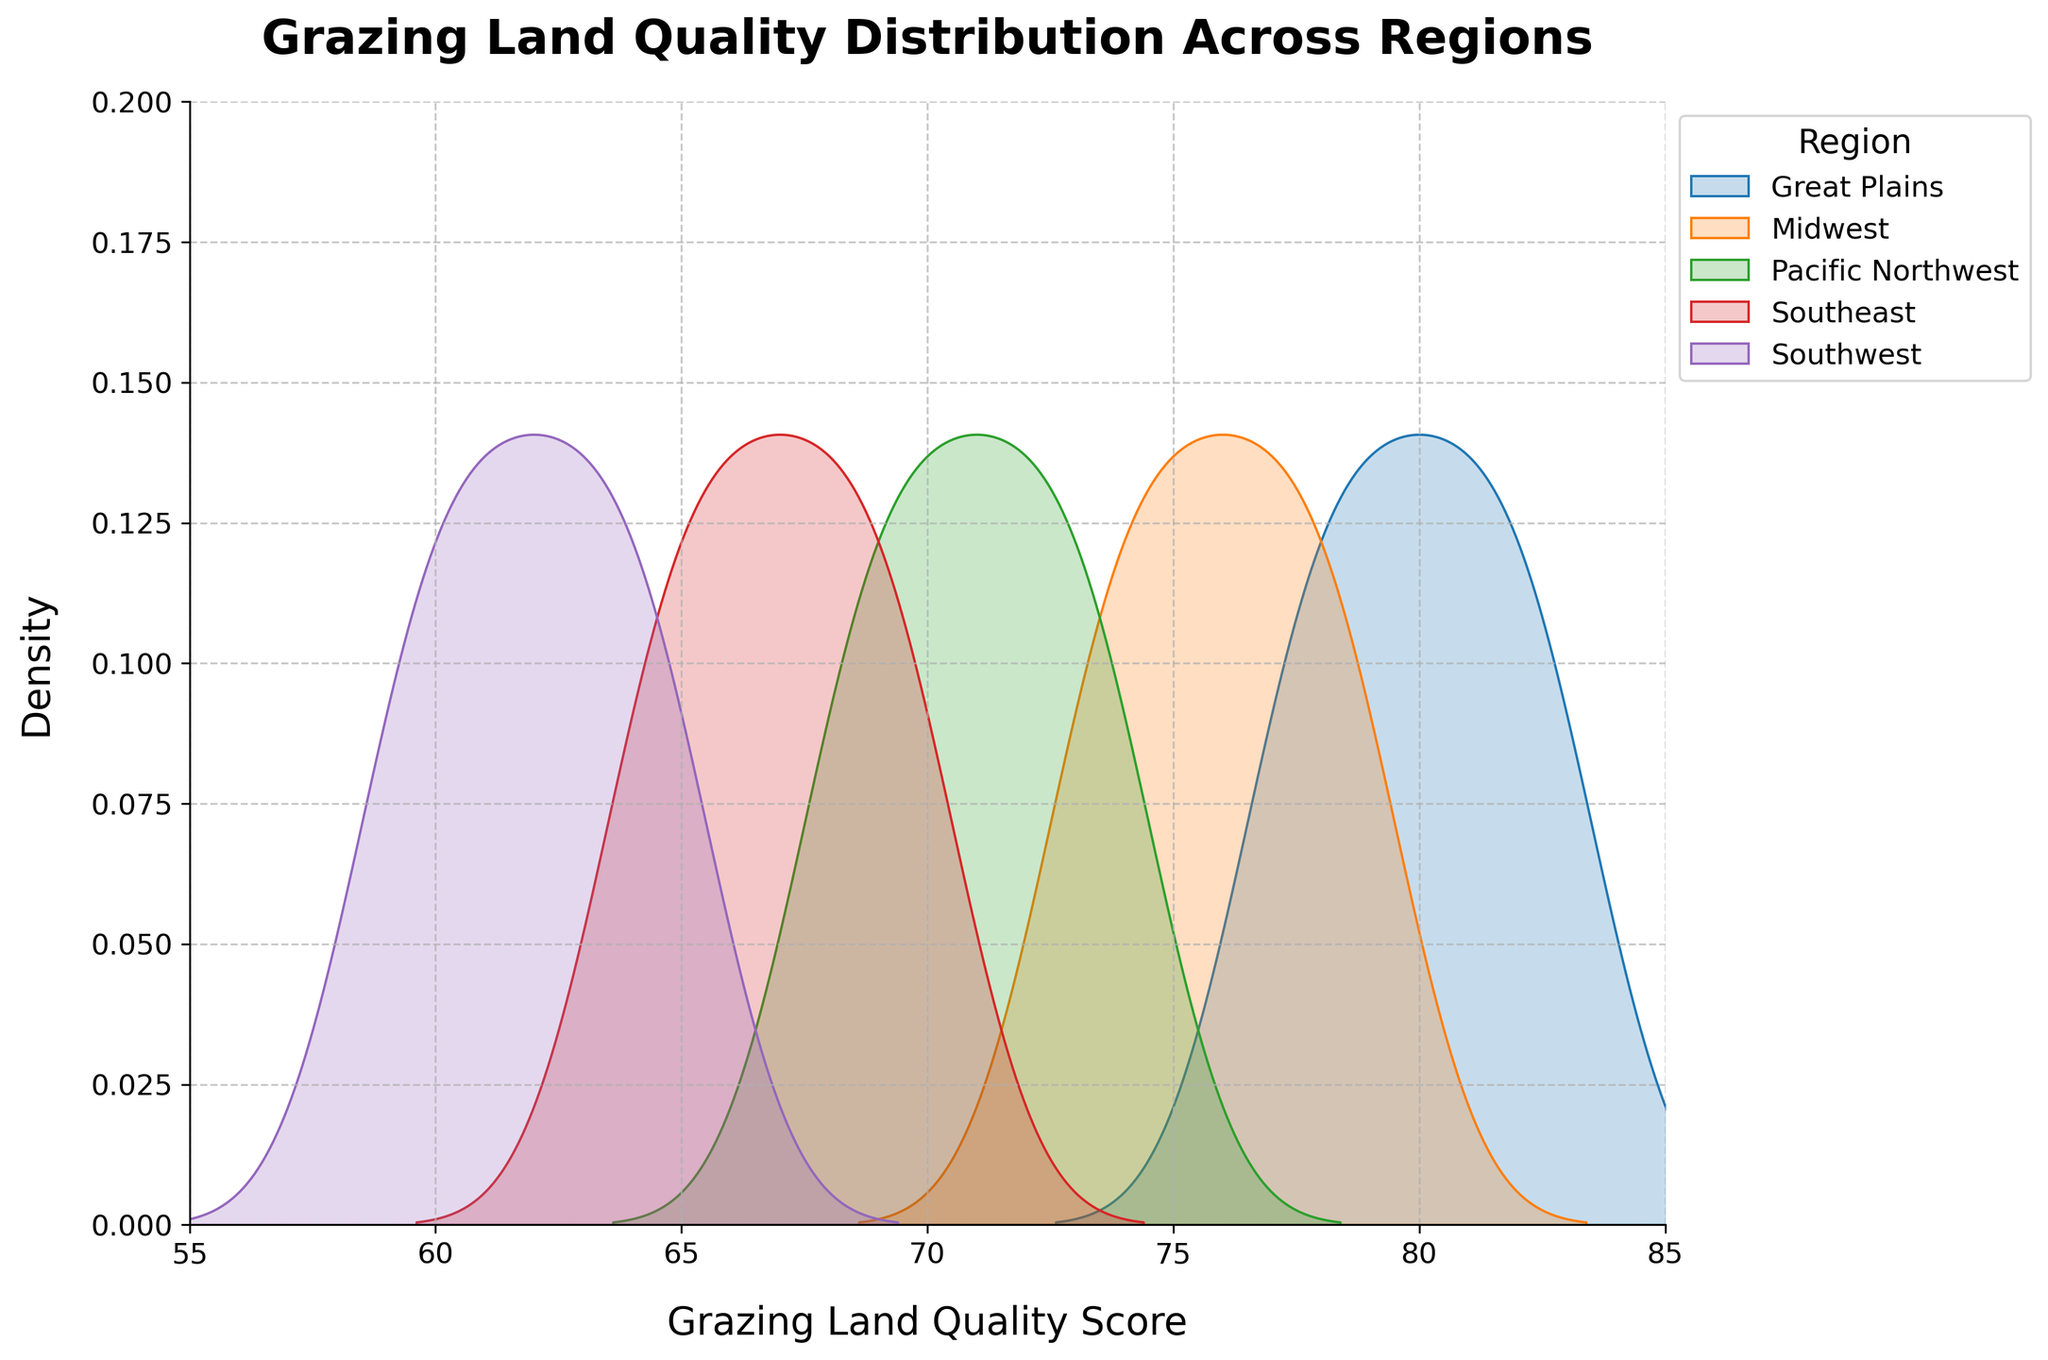What is the title of the figure? The title is generally clearly printed at the top of the figure. Here, the figure's title is "Grazing Land Quality Distribution Across Regions" as specified in the code.
Answer: Grazing Land Quality Distribution Across Regions What is the highest density value on the y-axis? By examining the y-axis of the plot, we can see that the highest density value is marked at 0.2.
Answer: 0.2 Which region has the peak density for the lowest Grazing Land Quality scores? By looking at the plot, we can see the peaks of the density plots for the lowest scores. The Southeast region, represented by the density peak around a score of 64-65, has the peak density for the lowest Grazing Land Quality scores.
Answer: Southeast Which region's density plot has the broadest spread of grazing land quality scores? Observing the span of different density plots, we notice the Great Plains region has a broader spread over approximately 77 to 83, compared to other regions.
Answer: Great Plains What is the Grazing Land Quality score range for the Pacific Northwest region? The density plot for the Pacific Northwest spans from about 68 to 74, which we can determine by the area where the density is greater than zero.
Answer: 68 to 74 How do the peaks of the Great Plains and Midwest density plots compare? By examining the density plots, we see that both the Great Plains and Midwest have notable peaks. The Great Plains' peak is slightly above 80, while the Midwest's peak is a bit lower, around 76-77.
Answer: Great Plains has a higher peak Which region has the most centralized distribution of Grazing Land Quality scores? From the density plots, the Midwest appears to be the most centralized, with a densest peak near the center of its distribution around the 76-77 range, indicating a narrow spread.
Answer: Midwest What are the approximate Grazing Land Quality score ranges for the Southeast and Southwest regions? By looking at the density plots, the Southeast spans approximately from 64 to 70, while the Southwest spans from around 59 to 65.
Answer: Southeast: 64 to 70, Southwest: 59 to 65 